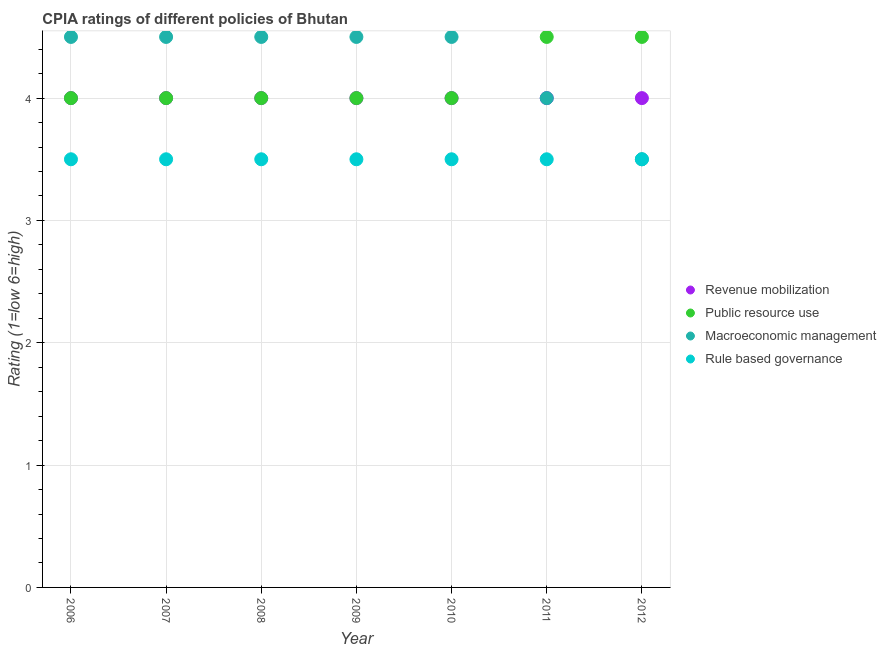How many different coloured dotlines are there?
Offer a terse response. 4. Across all years, what is the minimum cpia rating of revenue mobilization?
Provide a succinct answer. 4. In which year was the cpia rating of revenue mobilization maximum?
Make the answer very short. 2006. What is the difference between the cpia rating of public resource use in 2008 and that in 2009?
Provide a succinct answer. 0. What is the difference between the cpia rating of rule based governance in 2011 and the cpia rating of macroeconomic management in 2012?
Offer a very short reply. 0. What is the average cpia rating of revenue mobilization per year?
Offer a terse response. 4. Is the cpia rating of rule based governance in 2007 less than that in 2012?
Your response must be concise. No. Is the difference between the cpia rating of rule based governance in 2009 and 2012 greater than the difference between the cpia rating of revenue mobilization in 2009 and 2012?
Provide a succinct answer. No. What is the difference between the highest and the lowest cpia rating of public resource use?
Offer a terse response. 0.5. Is it the case that in every year, the sum of the cpia rating of revenue mobilization and cpia rating of public resource use is greater than the cpia rating of macroeconomic management?
Your response must be concise. Yes. How many dotlines are there?
Make the answer very short. 4. How many years are there in the graph?
Make the answer very short. 7. Does the graph contain grids?
Your answer should be compact. Yes. Where does the legend appear in the graph?
Provide a succinct answer. Center right. How many legend labels are there?
Make the answer very short. 4. What is the title of the graph?
Your answer should be very brief. CPIA ratings of different policies of Bhutan. Does "Plant species" appear as one of the legend labels in the graph?
Your response must be concise. No. What is the label or title of the Y-axis?
Offer a terse response. Rating (1=low 6=high). What is the Rating (1=low 6=high) of Revenue mobilization in 2006?
Your response must be concise. 4. What is the Rating (1=low 6=high) of Public resource use in 2006?
Provide a succinct answer. 4. What is the Rating (1=low 6=high) in Revenue mobilization in 2007?
Your answer should be compact. 4. What is the Rating (1=low 6=high) of Public resource use in 2007?
Offer a terse response. 4. What is the Rating (1=low 6=high) of Revenue mobilization in 2008?
Your answer should be compact. 4. What is the Rating (1=low 6=high) of Public resource use in 2008?
Make the answer very short. 4. What is the Rating (1=low 6=high) in Revenue mobilization in 2009?
Ensure brevity in your answer.  4. What is the Rating (1=low 6=high) of Public resource use in 2009?
Offer a terse response. 4. What is the Rating (1=low 6=high) in Public resource use in 2010?
Offer a terse response. 4. What is the Rating (1=low 6=high) of Macroeconomic management in 2010?
Provide a succinct answer. 4.5. What is the Rating (1=low 6=high) in Rule based governance in 2010?
Provide a short and direct response. 3.5. What is the Rating (1=low 6=high) in Revenue mobilization in 2011?
Your answer should be very brief. 4. What is the Rating (1=low 6=high) in Macroeconomic management in 2011?
Keep it short and to the point. 4. What is the Rating (1=low 6=high) of Macroeconomic management in 2012?
Your response must be concise. 3.5. What is the Rating (1=low 6=high) of Rule based governance in 2012?
Your answer should be compact. 3.5. Across all years, what is the maximum Rating (1=low 6=high) in Public resource use?
Give a very brief answer. 4.5. Across all years, what is the maximum Rating (1=low 6=high) in Rule based governance?
Ensure brevity in your answer.  3.5. Across all years, what is the minimum Rating (1=low 6=high) of Macroeconomic management?
Give a very brief answer. 3.5. Across all years, what is the minimum Rating (1=low 6=high) of Rule based governance?
Offer a very short reply. 3.5. What is the total Rating (1=low 6=high) of Revenue mobilization in the graph?
Ensure brevity in your answer.  28. What is the total Rating (1=low 6=high) in Public resource use in the graph?
Your answer should be very brief. 29. What is the total Rating (1=low 6=high) of Macroeconomic management in the graph?
Give a very brief answer. 30. What is the difference between the Rating (1=low 6=high) of Rule based governance in 2006 and that in 2007?
Provide a short and direct response. 0. What is the difference between the Rating (1=low 6=high) in Macroeconomic management in 2006 and that in 2008?
Your answer should be very brief. 0. What is the difference between the Rating (1=low 6=high) in Rule based governance in 2006 and that in 2008?
Offer a terse response. 0. What is the difference between the Rating (1=low 6=high) in Revenue mobilization in 2006 and that in 2009?
Offer a very short reply. 0. What is the difference between the Rating (1=low 6=high) of Public resource use in 2006 and that in 2009?
Provide a short and direct response. 0. What is the difference between the Rating (1=low 6=high) of Macroeconomic management in 2006 and that in 2009?
Your response must be concise. 0. What is the difference between the Rating (1=low 6=high) in Revenue mobilization in 2006 and that in 2010?
Your response must be concise. 0. What is the difference between the Rating (1=low 6=high) of Public resource use in 2006 and that in 2010?
Keep it short and to the point. 0. What is the difference between the Rating (1=low 6=high) of Macroeconomic management in 2006 and that in 2010?
Your response must be concise. 0. What is the difference between the Rating (1=low 6=high) in Rule based governance in 2006 and that in 2010?
Ensure brevity in your answer.  0. What is the difference between the Rating (1=low 6=high) in Revenue mobilization in 2006 and that in 2011?
Make the answer very short. 0. What is the difference between the Rating (1=low 6=high) of Macroeconomic management in 2006 and that in 2011?
Make the answer very short. 0.5. What is the difference between the Rating (1=low 6=high) in Revenue mobilization in 2006 and that in 2012?
Your answer should be very brief. 0. What is the difference between the Rating (1=low 6=high) in Macroeconomic management in 2007 and that in 2008?
Keep it short and to the point. 0. What is the difference between the Rating (1=low 6=high) of Rule based governance in 2007 and that in 2008?
Give a very brief answer. 0. What is the difference between the Rating (1=low 6=high) in Revenue mobilization in 2007 and that in 2009?
Your answer should be very brief. 0. What is the difference between the Rating (1=low 6=high) of Public resource use in 2007 and that in 2009?
Keep it short and to the point. 0. What is the difference between the Rating (1=low 6=high) of Macroeconomic management in 2007 and that in 2009?
Keep it short and to the point. 0. What is the difference between the Rating (1=low 6=high) of Rule based governance in 2007 and that in 2009?
Provide a succinct answer. 0. What is the difference between the Rating (1=low 6=high) of Macroeconomic management in 2007 and that in 2010?
Provide a succinct answer. 0. What is the difference between the Rating (1=low 6=high) of Rule based governance in 2007 and that in 2010?
Offer a very short reply. 0. What is the difference between the Rating (1=low 6=high) of Macroeconomic management in 2007 and that in 2011?
Keep it short and to the point. 0.5. What is the difference between the Rating (1=low 6=high) in Revenue mobilization in 2007 and that in 2012?
Your response must be concise. 0. What is the difference between the Rating (1=low 6=high) in Macroeconomic management in 2007 and that in 2012?
Make the answer very short. 1. What is the difference between the Rating (1=low 6=high) in Revenue mobilization in 2008 and that in 2009?
Keep it short and to the point. 0. What is the difference between the Rating (1=low 6=high) in Macroeconomic management in 2008 and that in 2009?
Your answer should be compact. 0. What is the difference between the Rating (1=low 6=high) in Public resource use in 2008 and that in 2010?
Give a very brief answer. 0. What is the difference between the Rating (1=low 6=high) in Rule based governance in 2008 and that in 2010?
Ensure brevity in your answer.  0. What is the difference between the Rating (1=low 6=high) of Revenue mobilization in 2008 and that in 2011?
Give a very brief answer. 0. What is the difference between the Rating (1=low 6=high) of Macroeconomic management in 2008 and that in 2011?
Offer a very short reply. 0.5. What is the difference between the Rating (1=low 6=high) of Revenue mobilization in 2008 and that in 2012?
Your response must be concise. 0. What is the difference between the Rating (1=low 6=high) in Public resource use in 2008 and that in 2012?
Keep it short and to the point. -0.5. What is the difference between the Rating (1=low 6=high) of Revenue mobilization in 2009 and that in 2010?
Your answer should be very brief. 0. What is the difference between the Rating (1=low 6=high) in Public resource use in 2009 and that in 2010?
Your answer should be compact. 0. What is the difference between the Rating (1=low 6=high) in Macroeconomic management in 2009 and that in 2010?
Keep it short and to the point. 0. What is the difference between the Rating (1=low 6=high) in Revenue mobilization in 2009 and that in 2011?
Provide a short and direct response. 0. What is the difference between the Rating (1=low 6=high) in Public resource use in 2009 and that in 2011?
Keep it short and to the point. -0.5. What is the difference between the Rating (1=low 6=high) of Rule based governance in 2009 and that in 2011?
Keep it short and to the point. 0. What is the difference between the Rating (1=low 6=high) in Macroeconomic management in 2009 and that in 2012?
Keep it short and to the point. 1. What is the difference between the Rating (1=low 6=high) in Rule based governance in 2009 and that in 2012?
Provide a short and direct response. 0. What is the difference between the Rating (1=low 6=high) in Revenue mobilization in 2010 and that in 2011?
Offer a very short reply. 0. What is the difference between the Rating (1=low 6=high) of Public resource use in 2010 and that in 2011?
Ensure brevity in your answer.  -0.5. What is the difference between the Rating (1=low 6=high) of Macroeconomic management in 2010 and that in 2011?
Provide a succinct answer. 0.5. What is the difference between the Rating (1=low 6=high) in Rule based governance in 2010 and that in 2011?
Make the answer very short. 0. What is the difference between the Rating (1=low 6=high) in Revenue mobilization in 2010 and that in 2012?
Provide a short and direct response. 0. What is the difference between the Rating (1=low 6=high) in Public resource use in 2010 and that in 2012?
Offer a very short reply. -0.5. What is the difference between the Rating (1=low 6=high) in Macroeconomic management in 2010 and that in 2012?
Your answer should be compact. 1. What is the difference between the Rating (1=low 6=high) of Rule based governance in 2010 and that in 2012?
Offer a terse response. 0. What is the difference between the Rating (1=low 6=high) of Macroeconomic management in 2011 and that in 2012?
Make the answer very short. 0.5. What is the difference between the Rating (1=low 6=high) of Revenue mobilization in 2006 and the Rating (1=low 6=high) of Macroeconomic management in 2007?
Offer a very short reply. -0.5. What is the difference between the Rating (1=low 6=high) of Public resource use in 2006 and the Rating (1=low 6=high) of Rule based governance in 2007?
Make the answer very short. 0.5. What is the difference between the Rating (1=low 6=high) in Macroeconomic management in 2006 and the Rating (1=low 6=high) in Rule based governance in 2007?
Offer a terse response. 1. What is the difference between the Rating (1=low 6=high) of Revenue mobilization in 2006 and the Rating (1=low 6=high) of Public resource use in 2008?
Keep it short and to the point. 0. What is the difference between the Rating (1=low 6=high) of Revenue mobilization in 2006 and the Rating (1=low 6=high) of Macroeconomic management in 2008?
Provide a succinct answer. -0.5. What is the difference between the Rating (1=low 6=high) in Macroeconomic management in 2006 and the Rating (1=low 6=high) in Rule based governance in 2008?
Provide a short and direct response. 1. What is the difference between the Rating (1=low 6=high) of Revenue mobilization in 2006 and the Rating (1=low 6=high) of Public resource use in 2009?
Provide a succinct answer. 0. What is the difference between the Rating (1=low 6=high) in Revenue mobilization in 2006 and the Rating (1=low 6=high) in Rule based governance in 2009?
Your response must be concise. 0.5. What is the difference between the Rating (1=low 6=high) of Public resource use in 2006 and the Rating (1=low 6=high) of Macroeconomic management in 2009?
Your response must be concise. -0.5. What is the difference between the Rating (1=low 6=high) in Macroeconomic management in 2006 and the Rating (1=low 6=high) in Rule based governance in 2009?
Offer a very short reply. 1. What is the difference between the Rating (1=low 6=high) of Macroeconomic management in 2006 and the Rating (1=low 6=high) of Rule based governance in 2010?
Keep it short and to the point. 1. What is the difference between the Rating (1=low 6=high) in Revenue mobilization in 2006 and the Rating (1=low 6=high) in Public resource use in 2011?
Your response must be concise. -0.5. What is the difference between the Rating (1=low 6=high) of Revenue mobilization in 2006 and the Rating (1=low 6=high) of Macroeconomic management in 2011?
Keep it short and to the point. 0. What is the difference between the Rating (1=low 6=high) in Public resource use in 2006 and the Rating (1=low 6=high) in Rule based governance in 2011?
Ensure brevity in your answer.  0.5. What is the difference between the Rating (1=low 6=high) in Revenue mobilization in 2006 and the Rating (1=low 6=high) in Public resource use in 2012?
Provide a short and direct response. -0.5. What is the difference between the Rating (1=low 6=high) in Public resource use in 2006 and the Rating (1=low 6=high) in Macroeconomic management in 2012?
Give a very brief answer. 0.5. What is the difference between the Rating (1=low 6=high) in Macroeconomic management in 2006 and the Rating (1=low 6=high) in Rule based governance in 2012?
Your answer should be very brief. 1. What is the difference between the Rating (1=low 6=high) of Revenue mobilization in 2007 and the Rating (1=low 6=high) of Public resource use in 2008?
Make the answer very short. 0. What is the difference between the Rating (1=low 6=high) in Revenue mobilization in 2007 and the Rating (1=low 6=high) in Rule based governance in 2008?
Your answer should be very brief. 0.5. What is the difference between the Rating (1=low 6=high) in Public resource use in 2007 and the Rating (1=low 6=high) in Macroeconomic management in 2008?
Your answer should be very brief. -0.5. What is the difference between the Rating (1=low 6=high) in Macroeconomic management in 2007 and the Rating (1=low 6=high) in Rule based governance in 2008?
Your answer should be very brief. 1. What is the difference between the Rating (1=low 6=high) in Revenue mobilization in 2007 and the Rating (1=low 6=high) in Public resource use in 2009?
Offer a terse response. 0. What is the difference between the Rating (1=low 6=high) of Public resource use in 2007 and the Rating (1=low 6=high) of Macroeconomic management in 2009?
Make the answer very short. -0.5. What is the difference between the Rating (1=low 6=high) of Revenue mobilization in 2007 and the Rating (1=low 6=high) of Rule based governance in 2010?
Make the answer very short. 0.5. What is the difference between the Rating (1=low 6=high) of Macroeconomic management in 2007 and the Rating (1=low 6=high) of Rule based governance in 2010?
Offer a very short reply. 1. What is the difference between the Rating (1=low 6=high) of Revenue mobilization in 2007 and the Rating (1=low 6=high) of Public resource use in 2011?
Give a very brief answer. -0.5. What is the difference between the Rating (1=low 6=high) of Revenue mobilization in 2007 and the Rating (1=low 6=high) of Macroeconomic management in 2011?
Provide a succinct answer. 0. What is the difference between the Rating (1=low 6=high) in Public resource use in 2007 and the Rating (1=low 6=high) in Rule based governance in 2012?
Ensure brevity in your answer.  0.5. What is the difference between the Rating (1=low 6=high) in Macroeconomic management in 2007 and the Rating (1=low 6=high) in Rule based governance in 2012?
Ensure brevity in your answer.  1. What is the difference between the Rating (1=low 6=high) in Revenue mobilization in 2008 and the Rating (1=low 6=high) in Public resource use in 2009?
Your response must be concise. 0. What is the difference between the Rating (1=low 6=high) in Revenue mobilization in 2008 and the Rating (1=low 6=high) in Macroeconomic management in 2009?
Keep it short and to the point. -0.5. What is the difference between the Rating (1=low 6=high) of Revenue mobilization in 2008 and the Rating (1=low 6=high) of Rule based governance in 2010?
Give a very brief answer. 0.5. What is the difference between the Rating (1=low 6=high) in Public resource use in 2008 and the Rating (1=low 6=high) in Rule based governance in 2010?
Give a very brief answer. 0.5. What is the difference between the Rating (1=low 6=high) of Revenue mobilization in 2008 and the Rating (1=low 6=high) of Public resource use in 2011?
Give a very brief answer. -0.5. What is the difference between the Rating (1=low 6=high) in Public resource use in 2008 and the Rating (1=low 6=high) in Macroeconomic management in 2011?
Your response must be concise. 0. What is the difference between the Rating (1=low 6=high) in Public resource use in 2008 and the Rating (1=low 6=high) in Macroeconomic management in 2012?
Offer a very short reply. 0.5. What is the difference between the Rating (1=low 6=high) of Revenue mobilization in 2009 and the Rating (1=low 6=high) of Public resource use in 2010?
Your response must be concise. 0. What is the difference between the Rating (1=low 6=high) in Revenue mobilization in 2009 and the Rating (1=low 6=high) in Rule based governance in 2010?
Ensure brevity in your answer.  0.5. What is the difference between the Rating (1=low 6=high) of Public resource use in 2009 and the Rating (1=low 6=high) of Rule based governance in 2010?
Provide a short and direct response. 0.5. What is the difference between the Rating (1=low 6=high) in Macroeconomic management in 2009 and the Rating (1=low 6=high) in Rule based governance in 2010?
Give a very brief answer. 1. What is the difference between the Rating (1=low 6=high) of Revenue mobilization in 2009 and the Rating (1=low 6=high) of Public resource use in 2011?
Provide a succinct answer. -0.5. What is the difference between the Rating (1=low 6=high) in Public resource use in 2009 and the Rating (1=low 6=high) in Rule based governance in 2011?
Keep it short and to the point. 0.5. What is the difference between the Rating (1=low 6=high) in Macroeconomic management in 2009 and the Rating (1=low 6=high) in Rule based governance in 2011?
Give a very brief answer. 1. What is the difference between the Rating (1=low 6=high) in Revenue mobilization in 2009 and the Rating (1=low 6=high) in Macroeconomic management in 2012?
Ensure brevity in your answer.  0.5. What is the difference between the Rating (1=low 6=high) of Revenue mobilization in 2009 and the Rating (1=low 6=high) of Rule based governance in 2012?
Ensure brevity in your answer.  0.5. What is the difference between the Rating (1=low 6=high) in Public resource use in 2009 and the Rating (1=low 6=high) in Macroeconomic management in 2012?
Your response must be concise. 0.5. What is the difference between the Rating (1=low 6=high) in Macroeconomic management in 2009 and the Rating (1=low 6=high) in Rule based governance in 2012?
Your answer should be compact. 1. What is the difference between the Rating (1=low 6=high) in Revenue mobilization in 2010 and the Rating (1=low 6=high) in Macroeconomic management in 2011?
Provide a short and direct response. 0. What is the difference between the Rating (1=low 6=high) in Revenue mobilization in 2010 and the Rating (1=low 6=high) in Rule based governance in 2011?
Offer a terse response. 0.5. What is the difference between the Rating (1=low 6=high) of Public resource use in 2010 and the Rating (1=low 6=high) of Macroeconomic management in 2011?
Make the answer very short. 0. What is the difference between the Rating (1=low 6=high) in Public resource use in 2010 and the Rating (1=low 6=high) in Rule based governance in 2011?
Offer a terse response. 0.5. What is the difference between the Rating (1=low 6=high) in Macroeconomic management in 2010 and the Rating (1=low 6=high) in Rule based governance in 2011?
Provide a short and direct response. 1. What is the difference between the Rating (1=low 6=high) of Revenue mobilization in 2010 and the Rating (1=low 6=high) of Rule based governance in 2012?
Offer a very short reply. 0.5. What is the difference between the Rating (1=low 6=high) of Public resource use in 2010 and the Rating (1=low 6=high) of Macroeconomic management in 2012?
Give a very brief answer. 0.5. What is the difference between the Rating (1=low 6=high) in Macroeconomic management in 2010 and the Rating (1=low 6=high) in Rule based governance in 2012?
Provide a short and direct response. 1. What is the difference between the Rating (1=low 6=high) of Revenue mobilization in 2011 and the Rating (1=low 6=high) of Rule based governance in 2012?
Your answer should be very brief. 0.5. What is the difference between the Rating (1=low 6=high) in Macroeconomic management in 2011 and the Rating (1=low 6=high) in Rule based governance in 2012?
Ensure brevity in your answer.  0.5. What is the average Rating (1=low 6=high) of Public resource use per year?
Offer a very short reply. 4.14. What is the average Rating (1=low 6=high) in Macroeconomic management per year?
Your answer should be very brief. 4.29. In the year 2006, what is the difference between the Rating (1=low 6=high) of Revenue mobilization and Rating (1=low 6=high) of Public resource use?
Provide a succinct answer. 0. In the year 2006, what is the difference between the Rating (1=low 6=high) of Revenue mobilization and Rating (1=low 6=high) of Rule based governance?
Offer a very short reply. 0.5. In the year 2006, what is the difference between the Rating (1=low 6=high) of Public resource use and Rating (1=low 6=high) of Macroeconomic management?
Your answer should be very brief. -0.5. In the year 2006, what is the difference between the Rating (1=low 6=high) of Public resource use and Rating (1=low 6=high) of Rule based governance?
Your answer should be very brief. 0.5. In the year 2007, what is the difference between the Rating (1=low 6=high) in Revenue mobilization and Rating (1=low 6=high) in Rule based governance?
Keep it short and to the point. 0.5. In the year 2007, what is the difference between the Rating (1=low 6=high) of Public resource use and Rating (1=low 6=high) of Rule based governance?
Ensure brevity in your answer.  0.5. In the year 2008, what is the difference between the Rating (1=low 6=high) in Revenue mobilization and Rating (1=low 6=high) in Public resource use?
Make the answer very short. 0. In the year 2008, what is the difference between the Rating (1=low 6=high) of Revenue mobilization and Rating (1=low 6=high) of Macroeconomic management?
Offer a terse response. -0.5. In the year 2008, what is the difference between the Rating (1=low 6=high) in Macroeconomic management and Rating (1=low 6=high) in Rule based governance?
Provide a succinct answer. 1. In the year 2009, what is the difference between the Rating (1=low 6=high) in Public resource use and Rating (1=low 6=high) in Macroeconomic management?
Offer a terse response. -0.5. In the year 2010, what is the difference between the Rating (1=low 6=high) of Public resource use and Rating (1=low 6=high) of Macroeconomic management?
Provide a succinct answer. -0.5. In the year 2010, what is the difference between the Rating (1=low 6=high) of Public resource use and Rating (1=low 6=high) of Rule based governance?
Provide a succinct answer. 0.5. In the year 2011, what is the difference between the Rating (1=low 6=high) of Public resource use and Rating (1=low 6=high) of Rule based governance?
Your answer should be compact. 1. In the year 2012, what is the difference between the Rating (1=low 6=high) in Revenue mobilization and Rating (1=low 6=high) in Macroeconomic management?
Your answer should be very brief. 0.5. In the year 2012, what is the difference between the Rating (1=low 6=high) in Revenue mobilization and Rating (1=low 6=high) in Rule based governance?
Offer a very short reply. 0.5. In the year 2012, what is the difference between the Rating (1=low 6=high) of Public resource use and Rating (1=low 6=high) of Macroeconomic management?
Provide a short and direct response. 1. In the year 2012, what is the difference between the Rating (1=low 6=high) in Public resource use and Rating (1=low 6=high) in Rule based governance?
Your answer should be very brief. 1. What is the ratio of the Rating (1=low 6=high) in Rule based governance in 2006 to that in 2007?
Your answer should be very brief. 1. What is the ratio of the Rating (1=low 6=high) in Revenue mobilization in 2006 to that in 2008?
Offer a terse response. 1. What is the ratio of the Rating (1=low 6=high) of Public resource use in 2006 to that in 2008?
Make the answer very short. 1. What is the ratio of the Rating (1=low 6=high) in Rule based governance in 2006 to that in 2008?
Ensure brevity in your answer.  1. What is the ratio of the Rating (1=low 6=high) of Revenue mobilization in 2006 to that in 2009?
Give a very brief answer. 1. What is the ratio of the Rating (1=low 6=high) of Public resource use in 2006 to that in 2009?
Your answer should be very brief. 1. What is the ratio of the Rating (1=low 6=high) in Macroeconomic management in 2006 to that in 2009?
Provide a succinct answer. 1. What is the ratio of the Rating (1=low 6=high) of Rule based governance in 2006 to that in 2009?
Ensure brevity in your answer.  1. What is the ratio of the Rating (1=low 6=high) in Macroeconomic management in 2006 to that in 2010?
Provide a short and direct response. 1. What is the ratio of the Rating (1=low 6=high) in Revenue mobilization in 2006 to that in 2011?
Your answer should be compact. 1. What is the ratio of the Rating (1=low 6=high) of Public resource use in 2006 to that in 2011?
Your response must be concise. 0.89. What is the ratio of the Rating (1=low 6=high) in Rule based governance in 2006 to that in 2011?
Your answer should be very brief. 1. What is the ratio of the Rating (1=low 6=high) of Revenue mobilization in 2006 to that in 2012?
Provide a short and direct response. 1. What is the ratio of the Rating (1=low 6=high) in Public resource use in 2006 to that in 2012?
Keep it short and to the point. 0.89. What is the ratio of the Rating (1=low 6=high) in Revenue mobilization in 2007 to that in 2008?
Ensure brevity in your answer.  1. What is the ratio of the Rating (1=low 6=high) of Public resource use in 2007 to that in 2008?
Ensure brevity in your answer.  1. What is the ratio of the Rating (1=low 6=high) in Macroeconomic management in 2007 to that in 2008?
Offer a very short reply. 1. What is the ratio of the Rating (1=low 6=high) in Revenue mobilization in 2007 to that in 2009?
Your answer should be very brief. 1. What is the ratio of the Rating (1=low 6=high) of Public resource use in 2007 to that in 2009?
Your response must be concise. 1. What is the ratio of the Rating (1=low 6=high) of Revenue mobilization in 2007 to that in 2010?
Your answer should be very brief. 1. What is the ratio of the Rating (1=low 6=high) in Public resource use in 2007 to that in 2010?
Offer a very short reply. 1. What is the ratio of the Rating (1=low 6=high) in Rule based governance in 2007 to that in 2010?
Provide a succinct answer. 1. What is the ratio of the Rating (1=low 6=high) of Public resource use in 2007 to that in 2011?
Offer a very short reply. 0.89. What is the ratio of the Rating (1=low 6=high) in Macroeconomic management in 2007 to that in 2011?
Ensure brevity in your answer.  1.12. What is the ratio of the Rating (1=low 6=high) in Revenue mobilization in 2007 to that in 2012?
Give a very brief answer. 1. What is the ratio of the Rating (1=low 6=high) in Macroeconomic management in 2007 to that in 2012?
Make the answer very short. 1.29. What is the ratio of the Rating (1=low 6=high) of Rule based governance in 2007 to that in 2012?
Keep it short and to the point. 1. What is the ratio of the Rating (1=low 6=high) of Revenue mobilization in 2008 to that in 2009?
Offer a very short reply. 1. What is the ratio of the Rating (1=low 6=high) of Macroeconomic management in 2008 to that in 2009?
Give a very brief answer. 1. What is the ratio of the Rating (1=low 6=high) of Macroeconomic management in 2008 to that in 2010?
Provide a short and direct response. 1. What is the ratio of the Rating (1=low 6=high) in Rule based governance in 2008 to that in 2010?
Your answer should be compact. 1. What is the ratio of the Rating (1=low 6=high) of Public resource use in 2008 to that in 2011?
Keep it short and to the point. 0.89. What is the ratio of the Rating (1=low 6=high) of Public resource use in 2008 to that in 2012?
Make the answer very short. 0.89. What is the ratio of the Rating (1=low 6=high) in Rule based governance in 2008 to that in 2012?
Provide a short and direct response. 1. What is the ratio of the Rating (1=low 6=high) of Public resource use in 2009 to that in 2010?
Provide a short and direct response. 1. What is the ratio of the Rating (1=low 6=high) of Revenue mobilization in 2009 to that in 2011?
Offer a very short reply. 1. What is the ratio of the Rating (1=low 6=high) of Public resource use in 2009 to that in 2011?
Your response must be concise. 0.89. What is the ratio of the Rating (1=low 6=high) in Macroeconomic management in 2009 to that in 2011?
Your answer should be very brief. 1.12. What is the ratio of the Rating (1=low 6=high) of Public resource use in 2009 to that in 2012?
Offer a very short reply. 0.89. What is the ratio of the Rating (1=low 6=high) of Rule based governance in 2009 to that in 2012?
Your response must be concise. 1. What is the ratio of the Rating (1=low 6=high) of Revenue mobilization in 2010 to that in 2011?
Offer a very short reply. 1. What is the ratio of the Rating (1=low 6=high) of Revenue mobilization in 2010 to that in 2012?
Offer a very short reply. 1. What is the ratio of the Rating (1=low 6=high) in Public resource use in 2010 to that in 2012?
Offer a terse response. 0.89. What is the ratio of the Rating (1=low 6=high) of Macroeconomic management in 2011 to that in 2012?
Give a very brief answer. 1.14. What is the difference between the highest and the second highest Rating (1=low 6=high) of Revenue mobilization?
Your answer should be compact. 0. What is the difference between the highest and the second highest Rating (1=low 6=high) of Macroeconomic management?
Give a very brief answer. 0. What is the difference between the highest and the lowest Rating (1=low 6=high) of Revenue mobilization?
Your answer should be compact. 0. What is the difference between the highest and the lowest Rating (1=low 6=high) in Macroeconomic management?
Provide a succinct answer. 1. 